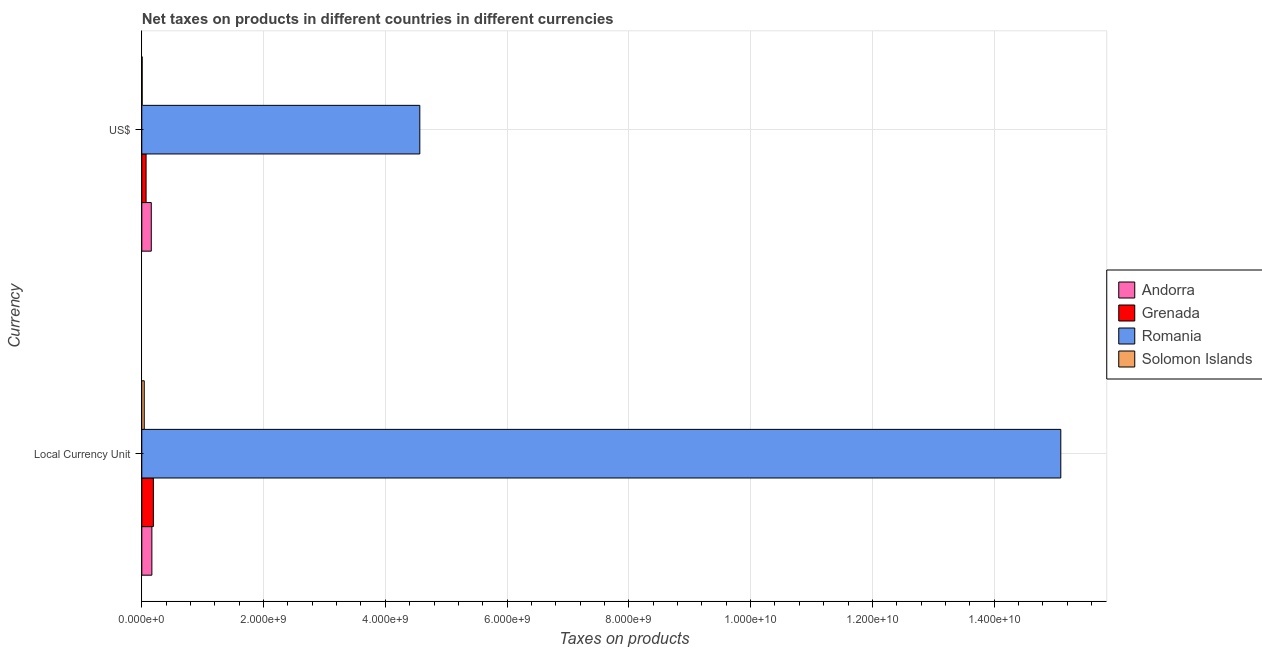How many different coloured bars are there?
Give a very brief answer. 4. How many groups of bars are there?
Your response must be concise. 2. Are the number of bars per tick equal to the number of legend labels?
Ensure brevity in your answer.  Yes. How many bars are there on the 2nd tick from the top?
Keep it short and to the point. 4. What is the label of the 1st group of bars from the top?
Your answer should be very brief. US$. What is the net taxes in constant 2005 us$ in Romania?
Provide a succinct answer. 1.51e+1. Across all countries, what is the maximum net taxes in constant 2005 us$?
Keep it short and to the point. 1.51e+1. Across all countries, what is the minimum net taxes in constant 2005 us$?
Offer a terse response. 4.03e+07. In which country was the net taxes in us$ maximum?
Offer a terse response. Romania. In which country was the net taxes in constant 2005 us$ minimum?
Make the answer very short. Solomon Islands. What is the total net taxes in us$ in the graph?
Your answer should be very brief. 4.80e+09. What is the difference between the net taxes in us$ in Andorra and that in Solomon Islands?
Your answer should be compact. 1.50e+08. What is the difference between the net taxes in us$ in Andorra and the net taxes in constant 2005 us$ in Romania?
Your answer should be compact. -1.49e+1. What is the average net taxes in us$ per country?
Provide a succinct answer. 1.20e+09. What is the difference between the net taxes in constant 2005 us$ and net taxes in us$ in Romania?
Your response must be concise. 1.05e+1. What is the ratio of the net taxes in us$ in Grenada to that in Andorra?
Offer a very short reply. 0.45. In how many countries, is the net taxes in us$ greater than the average net taxes in us$ taken over all countries?
Ensure brevity in your answer.  1. What does the 1st bar from the top in Local Currency Unit represents?
Your answer should be compact. Solomon Islands. What does the 3rd bar from the bottom in US$ represents?
Keep it short and to the point. Romania. How many bars are there?
Your answer should be compact. 8. How many countries are there in the graph?
Ensure brevity in your answer.  4. Are the values on the major ticks of X-axis written in scientific E-notation?
Provide a succinct answer. Yes. Does the graph contain grids?
Your answer should be very brief. Yes. How many legend labels are there?
Ensure brevity in your answer.  4. What is the title of the graph?
Give a very brief answer. Net taxes on products in different countries in different currencies. What is the label or title of the X-axis?
Your answer should be compact. Taxes on products. What is the label or title of the Y-axis?
Give a very brief answer. Currency. What is the Taxes on products of Andorra in Local Currency Unit?
Provide a succinct answer. 1.66e+08. What is the Taxes on products in Grenada in Local Currency Unit?
Keep it short and to the point. 1.90e+08. What is the Taxes on products in Romania in Local Currency Unit?
Your answer should be very brief. 1.51e+1. What is the Taxes on products in Solomon Islands in Local Currency Unit?
Provide a succinct answer. 4.03e+07. What is the Taxes on products of Andorra in US$?
Your answer should be very brief. 1.56e+08. What is the Taxes on products in Grenada in US$?
Your answer should be very brief. 7.03e+07. What is the Taxes on products of Romania in US$?
Provide a succinct answer. 4.57e+09. What is the Taxes on products of Solomon Islands in US$?
Your response must be concise. 5.98e+06. Across all Currency, what is the maximum Taxes on products of Andorra?
Your response must be concise. 1.66e+08. Across all Currency, what is the maximum Taxes on products of Grenada?
Make the answer very short. 1.90e+08. Across all Currency, what is the maximum Taxes on products in Romania?
Offer a very short reply. 1.51e+1. Across all Currency, what is the maximum Taxes on products of Solomon Islands?
Your answer should be compact. 4.03e+07. Across all Currency, what is the minimum Taxes on products of Andorra?
Offer a terse response. 1.56e+08. Across all Currency, what is the minimum Taxes on products of Grenada?
Your answer should be very brief. 7.03e+07. Across all Currency, what is the minimum Taxes on products in Romania?
Keep it short and to the point. 4.57e+09. Across all Currency, what is the minimum Taxes on products of Solomon Islands?
Keep it short and to the point. 5.98e+06. What is the total Taxes on products of Andorra in the graph?
Offer a terse response. 3.21e+08. What is the total Taxes on products of Grenada in the graph?
Provide a succinct answer. 2.60e+08. What is the total Taxes on products in Romania in the graph?
Give a very brief answer. 1.97e+1. What is the total Taxes on products of Solomon Islands in the graph?
Provide a succinct answer. 4.63e+07. What is the difference between the Taxes on products in Andorra in Local Currency Unit and that in US$?
Your answer should be very brief. 9.75e+06. What is the difference between the Taxes on products in Grenada in Local Currency Unit and that in US$?
Offer a very short reply. 1.20e+08. What is the difference between the Taxes on products of Romania in Local Currency Unit and that in US$?
Offer a terse response. 1.05e+1. What is the difference between the Taxes on products of Solomon Islands in Local Currency Unit and that in US$?
Offer a terse response. 3.44e+07. What is the difference between the Taxes on products in Andorra in Local Currency Unit and the Taxes on products in Grenada in US$?
Provide a succinct answer. 9.53e+07. What is the difference between the Taxes on products of Andorra in Local Currency Unit and the Taxes on products of Romania in US$?
Your response must be concise. -4.40e+09. What is the difference between the Taxes on products in Andorra in Local Currency Unit and the Taxes on products in Solomon Islands in US$?
Give a very brief answer. 1.60e+08. What is the difference between the Taxes on products of Grenada in Local Currency Unit and the Taxes on products of Romania in US$?
Give a very brief answer. -4.38e+09. What is the difference between the Taxes on products of Grenada in Local Currency Unit and the Taxes on products of Solomon Islands in US$?
Offer a very short reply. 1.84e+08. What is the difference between the Taxes on products of Romania in Local Currency Unit and the Taxes on products of Solomon Islands in US$?
Keep it short and to the point. 1.51e+1. What is the average Taxes on products in Andorra per Currency?
Ensure brevity in your answer.  1.61e+08. What is the average Taxes on products of Grenada per Currency?
Provide a short and direct response. 1.30e+08. What is the average Taxes on products of Romania per Currency?
Your answer should be very brief. 9.83e+09. What is the average Taxes on products in Solomon Islands per Currency?
Keep it short and to the point. 2.32e+07. What is the difference between the Taxes on products of Andorra and Taxes on products of Grenada in Local Currency Unit?
Keep it short and to the point. -2.43e+07. What is the difference between the Taxes on products in Andorra and Taxes on products in Romania in Local Currency Unit?
Your answer should be very brief. -1.49e+1. What is the difference between the Taxes on products of Andorra and Taxes on products of Solomon Islands in Local Currency Unit?
Keep it short and to the point. 1.25e+08. What is the difference between the Taxes on products of Grenada and Taxes on products of Romania in Local Currency Unit?
Your answer should be compact. -1.49e+1. What is the difference between the Taxes on products in Grenada and Taxes on products in Solomon Islands in Local Currency Unit?
Your answer should be compact. 1.50e+08. What is the difference between the Taxes on products in Romania and Taxes on products in Solomon Islands in Local Currency Unit?
Your answer should be very brief. 1.51e+1. What is the difference between the Taxes on products in Andorra and Taxes on products in Grenada in US$?
Provide a succinct answer. 8.55e+07. What is the difference between the Taxes on products of Andorra and Taxes on products of Romania in US$?
Your answer should be compact. -4.41e+09. What is the difference between the Taxes on products of Andorra and Taxes on products of Solomon Islands in US$?
Provide a succinct answer. 1.50e+08. What is the difference between the Taxes on products in Grenada and Taxes on products in Romania in US$?
Offer a very short reply. -4.50e+09. What is the difference between the Taxes on products in Grenada and Taxes on products in Solomon Islands in US$?
Your answer should be very brief. 6.44e+07. What is the difference between the Taxes on products in Romania and Taxes on products in Solomon Islands in US$?
Your answer should be very brief. 4.56e+09. What is the ratio of the Taxes on products in Andorra in Local Currency Unit to that in US$?
Provide a succinct answer. 1.06. What is the ratio of the Taxes on products in Romania in Local Currency Unit to that in US$?
Provide a short and direct response. 3.31. What is the ratio of the Taxes on products in Solomon Islands in Local Currency Unit to that in US$?
Ensure brevity in your answer.  6.75. What is the difference between the highest and the second highest Taxes on products of Andorra?
Make the answer very short. 9.75e+06. What is the difference between the highest and the second highest Taxes on products of Grenada?
Offer a terse response. 1.20e+08. What is the difference between the highest and the second highest Taxes on products of Romania?
Ensure brevity in your answer.  1.05e+1. What is the difference between the highest and the second highest Taxes on products in Solomon Islands?
Your response must be concise. 3.44e+07. What is the difference between the highest and the lowest Taxes on products in Andorra?
Your answer should be compact. 9.75e+06. What is the difference between the highest and the lowest Taxes on products in Grenada?
Offer a terse response. 1.20e+08. What is the difference between the highest and the lowest Taxes on products of Romania?
Provide a short and direct response. 1.05e+1. What is the difference between the highest and the lowest Taxes on products in Solomon Islands?
Give a very brief answer. 3.44e+07. 